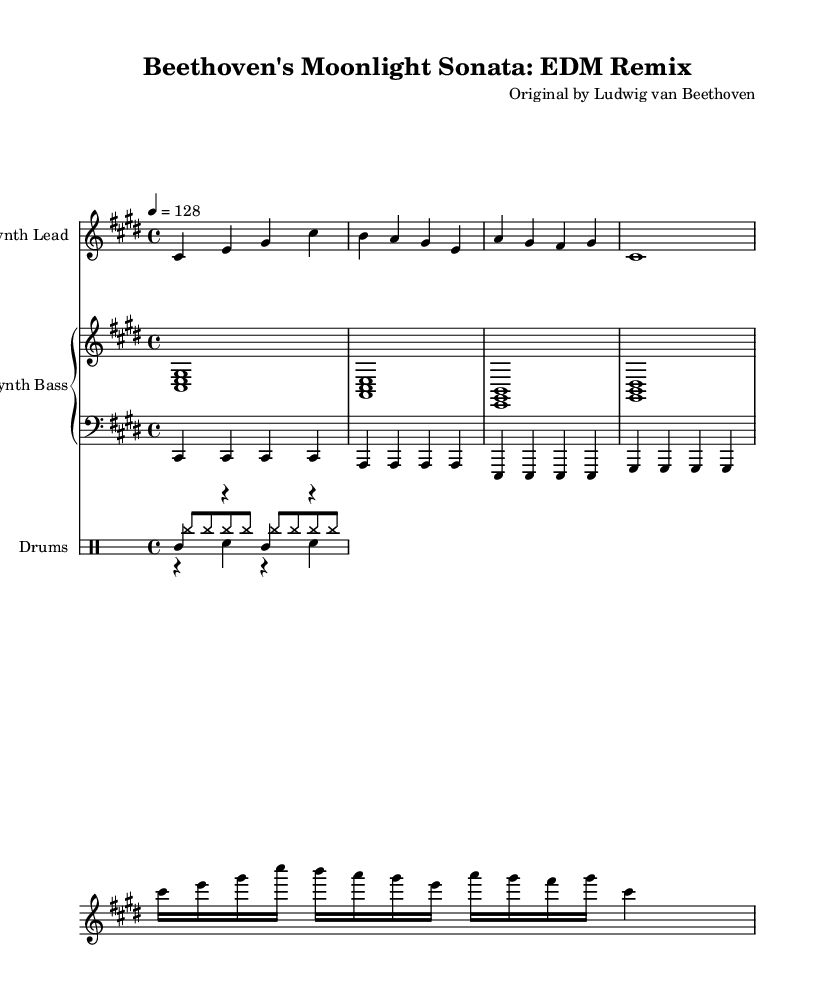What is the key signature of this music? The key signature is two sharps, which designate the key of C sharp minor. This is determined by looking at the key signature at the beginning of the staff.
Answer: C sharp minor What is the time signature of this piece? The time signature is 4/4, indicated at the beginning of the score. This tells us that there are four beats per measure.
Answer: 4/4 What is the tempo marking for this song? The tempo marking is quarter note equals 128, which indicates the beats per minute for the performance. This can be found in the tempo instruction at the beginning of the score.
Answer: 128 How many measures are in the melody section? The melody consists of four measures, which can be counted by observing the vertical bar lines separating the four segments of music.
Answer: 4 What is the main rhythm pattern for the kick drum? The kick drum pattern consists of a quarter note followed by a rest, repeated through two measures. This can be observed in the drum staff, noticing the kick drum notation in the drum voice.
Answer: Quarter note and rest pattern Which composer is the original of this piece? The original piece is composed by Ludwig van Beethoven, as stated in the header of the score.
Answer: Ludwig van Beethoven What style does this piece represent? This piece represents an EDM remix of a classical sonata, evident from the contemporary elements in its arrangement and the use of electronic instruments.
Answer: EDM remix 